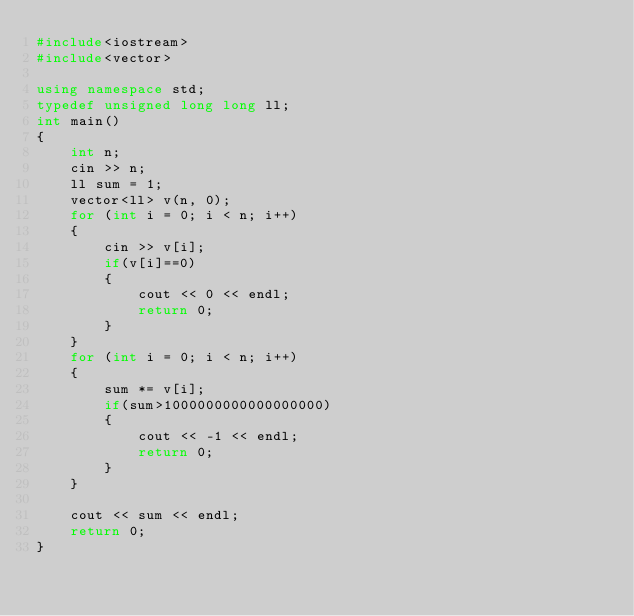Convert code to text. <code><loc_0><loc_0><loc_500><loc_500><_C++_>#include<iostream>
#include<vector>

using namespace std;
typedef unsigned long long ll;
int main()
{
    int n;
    cin >> n;
    ll sum = 1;
    vector<ll> v(n, 0);
    for (int i = 0; i < n; i++)
    {
        cin >> v[i];
        if(v[i]==0)
        {
            cout << 0 << endl;
            return 0;
        }
    }
    for (int i = 0; i < n; i++)
    {
        sum *= v[i];
        if(sum>1000000000000000000)
        {
            cout << -1 << endl;
            return 0;
        }
    }

    cout << sum << endl;
    return 0;
}</code> 